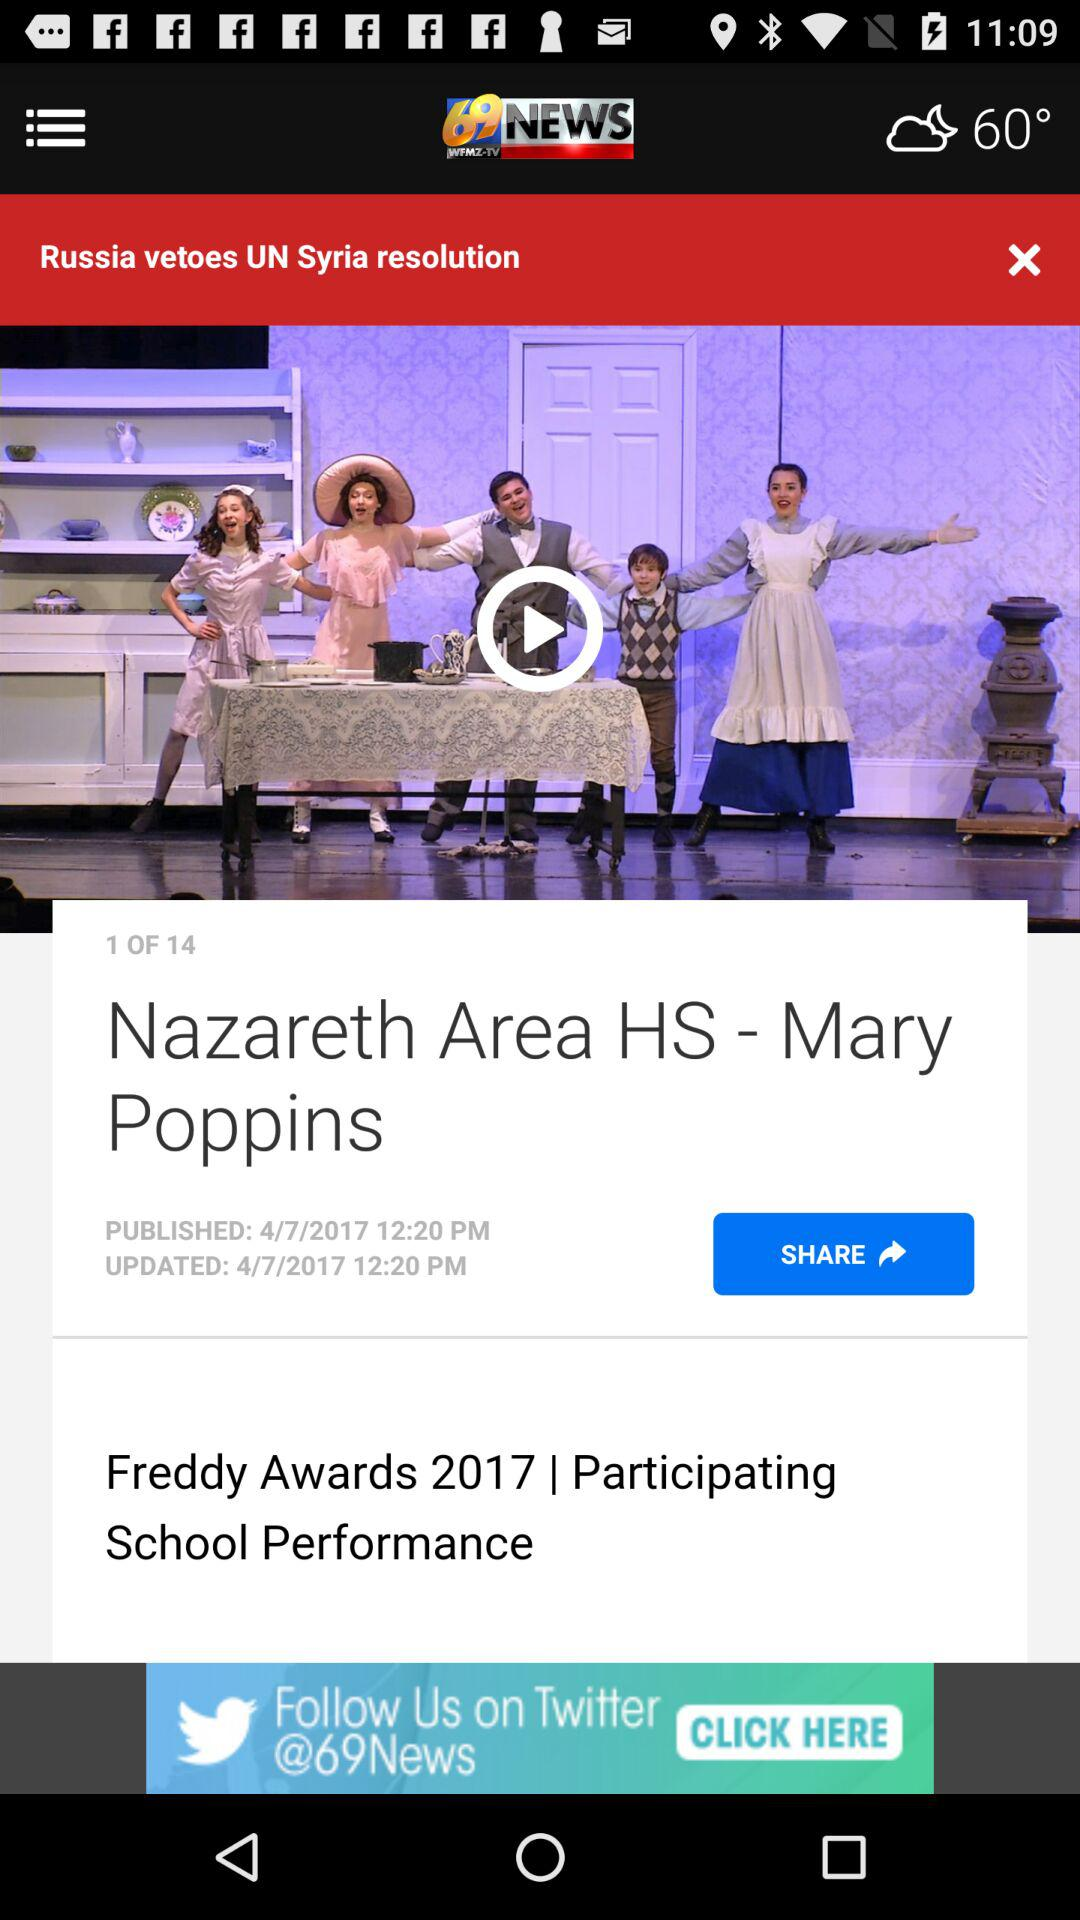What is the publication date? The publication date is 4/7/2017. 